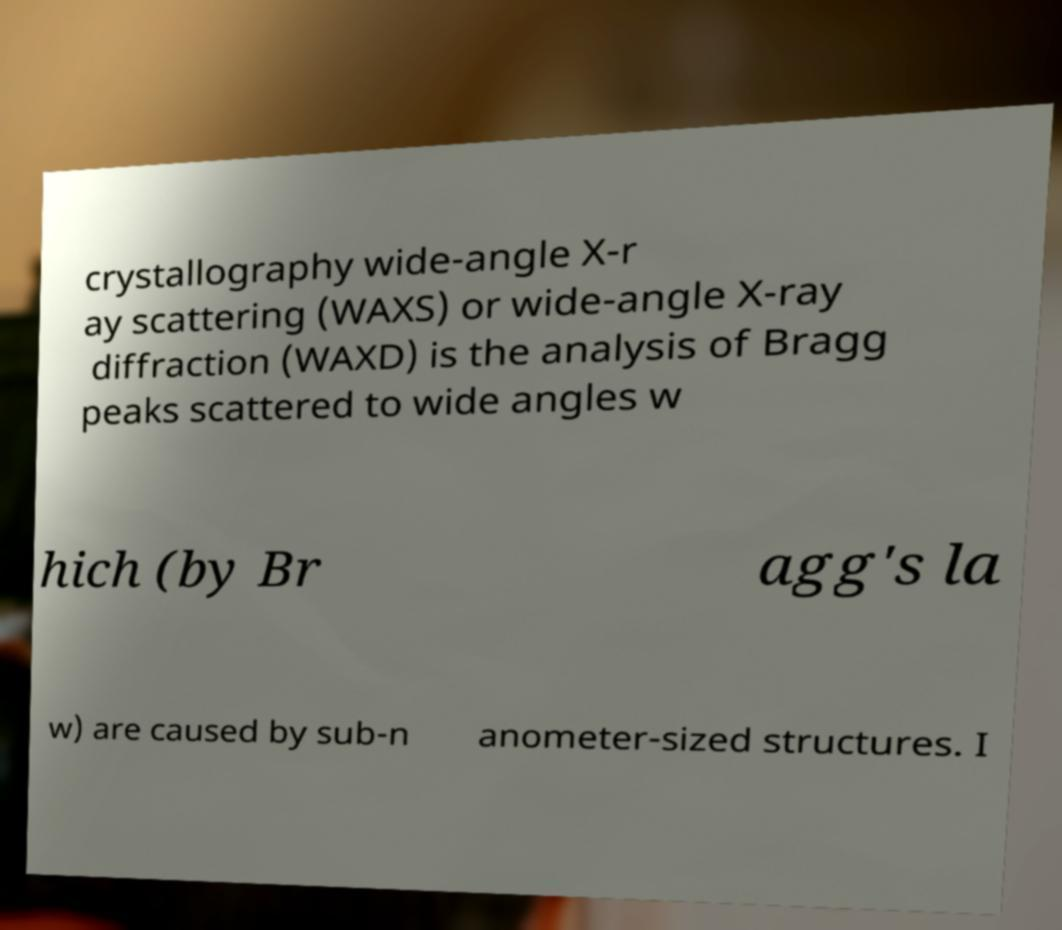Please identify and transcribe the text found in this image. crystallography wide-angle X-r ay scattering (WAXS) or wide-angle X-ray diffraction (WAXD) is the analysis of Bragg peaks scattered to wide angles w hich (by Br agg's la w) are caused by sub-n anometer-sized structures. I 